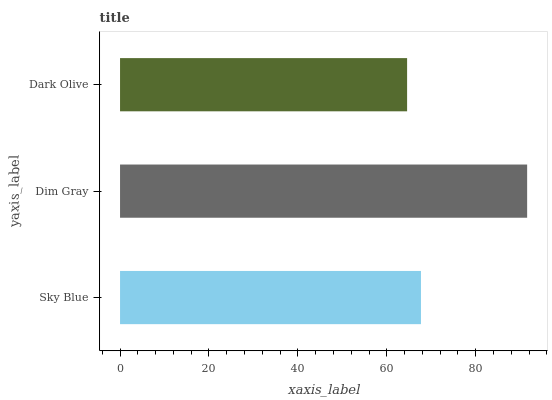Is Dark Olive the minimum?
Answer yes or no. Yes. Is Dim Gray the maximum?
Answer yes or no. Yes. Is Dim Gray the minimum?
Answer yes or no. No. Is Dark Olive the maximum?
Answer yes or no. No. Is Dim Gray greater than Dark Olive?
Answer yes or no. Yes. Is Dark Olive less than Dim Gray?
Answer yes or no. Yes. Is Dark Olive greater than Dim Gray?
Answer yes or no. No. Is Dim Gray less than Dark Olive?
Answer yes or no. No. Is Sky Blue the high median?
Answer yes or no. Yes. Is Sky Blue the low median?
Answer yes or no. Yes. Is Dim Gray the high median?
Answer yes or no. No. Is Dark Olive the low median?
Answer yes or no. No. 